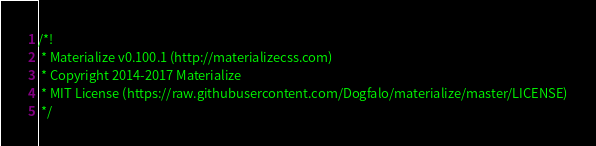<code> <loc_0><loc_0><loc_500><loc_500><_JavaScript_>/*!
 * Materialize v0.100.1 (http://materializecss.com)
 * Copyright 2014-2017 Materialize
 * MIT License (https://raw.githubusercontent.com/Dogfalo/materialize/master/LICENSE)
 */</code> 